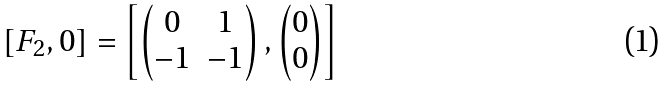Convert formula to latex. <formula><loc_0><loc_0><loc_500><loc_500>[ F _ { 2 } , 0 ] = \left [ \begin{pmatrix} 0 & 1 \\ - 1 & - 1 \end{pmatrix} , \begin{pmatrix} 0 \\ 0 \end{pmatrix} \right ]</formula> 